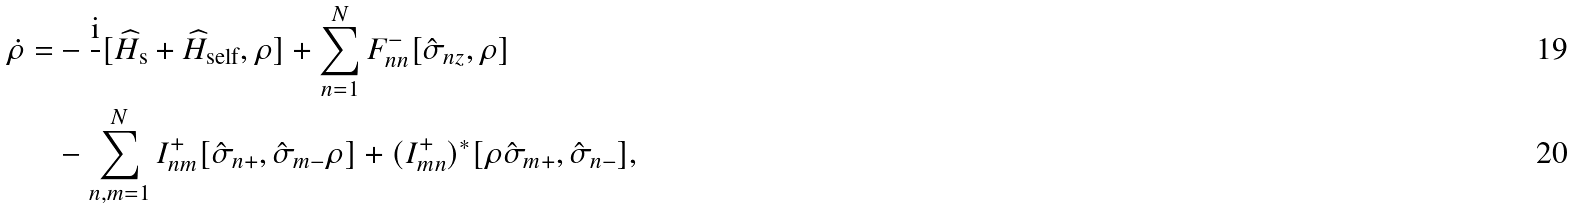Convert formula to latex. <formula><loc_0><loc_0><loc_500><loc_500>\dot { \rho } = & - \frac { \text {i} } { } [ \widehat { H } _ { \text {s} } + \widehat { H } _ { \text {self} } , \rho ] + \sum _ { n = 1 } ^ { N } F ^ { - } _ { n n } [ \hat { \sigma } _ { n z } , \rho ] \\ & - \sum _ { n , m = 1 } ^ { N } I _ { n m } ^ { + } [ \hat { \sigma } _ { n + } , \hat { \sigma } _ { m - } \rho ] + ( I _ { m n } ^ { + } ) ^ { * } [ \rho \hat { \sigma } _ { m + } , \hat { \sigma } _ { n - } ] ,</formula> 